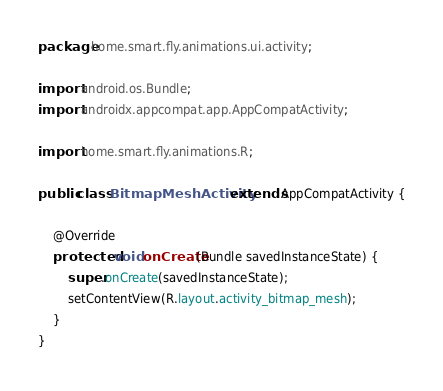<code> <loc_0><loc_0><loc_500><loc_500><_Java_>package home.smart.fly.animations.ui.activity;

import android.os.Bundle;
import androidx.appcompat.app.AppCompatActivity;

import home.smart.fly.animations.R;

public class BitmapMeshActivity extends AppCompatActivity {

    @Override
    protected void onCreate(Bundle savedInstanceState) {
        super.onCreate(savedInstanceState);
        setContentView(R.layout.activity_bitmap_mesh);
    }
}
</code> 